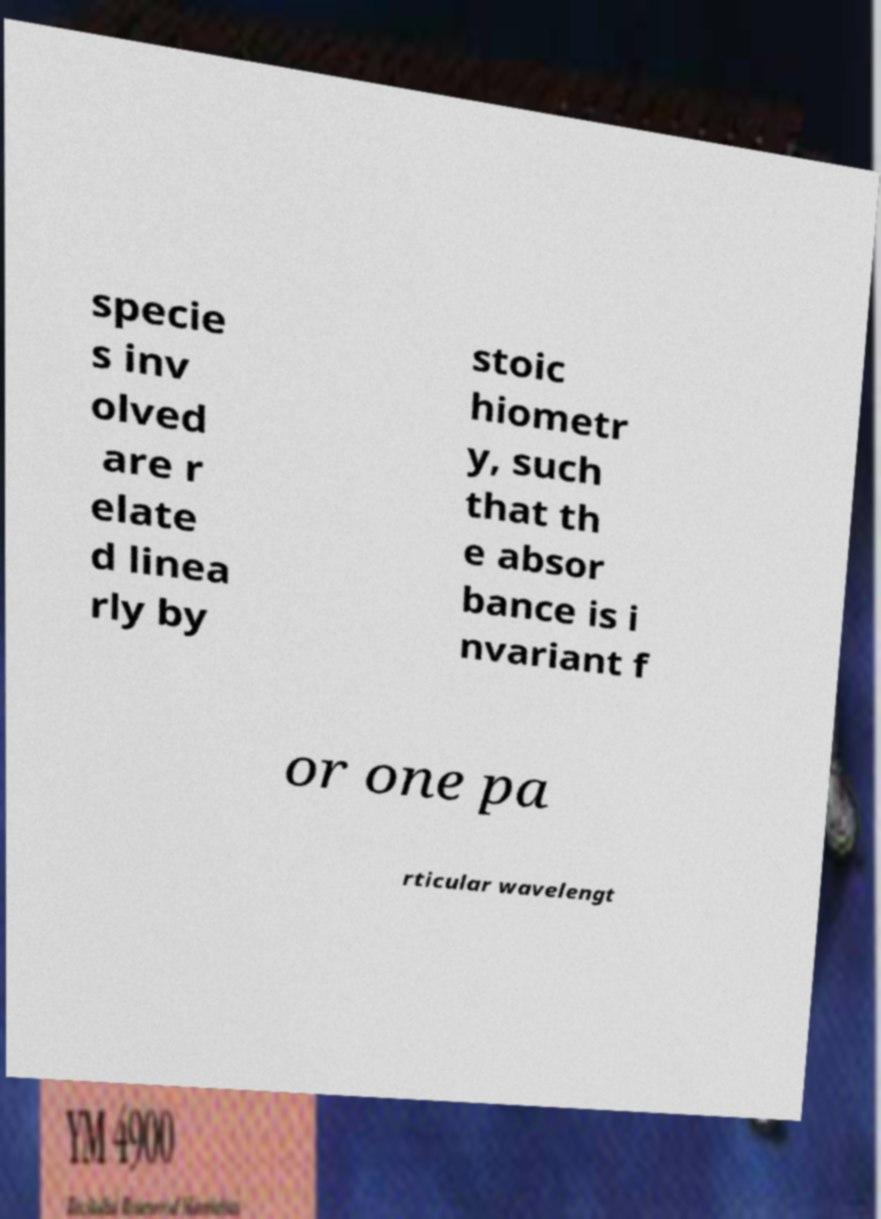For documentation purposes, I need the text within this image transcribed. Could you provide that? specie s inv olved are r elate d linea rly by stoic hiometr y, such that th e absor bance is i nvariant f or one pa rticular wavelengt 